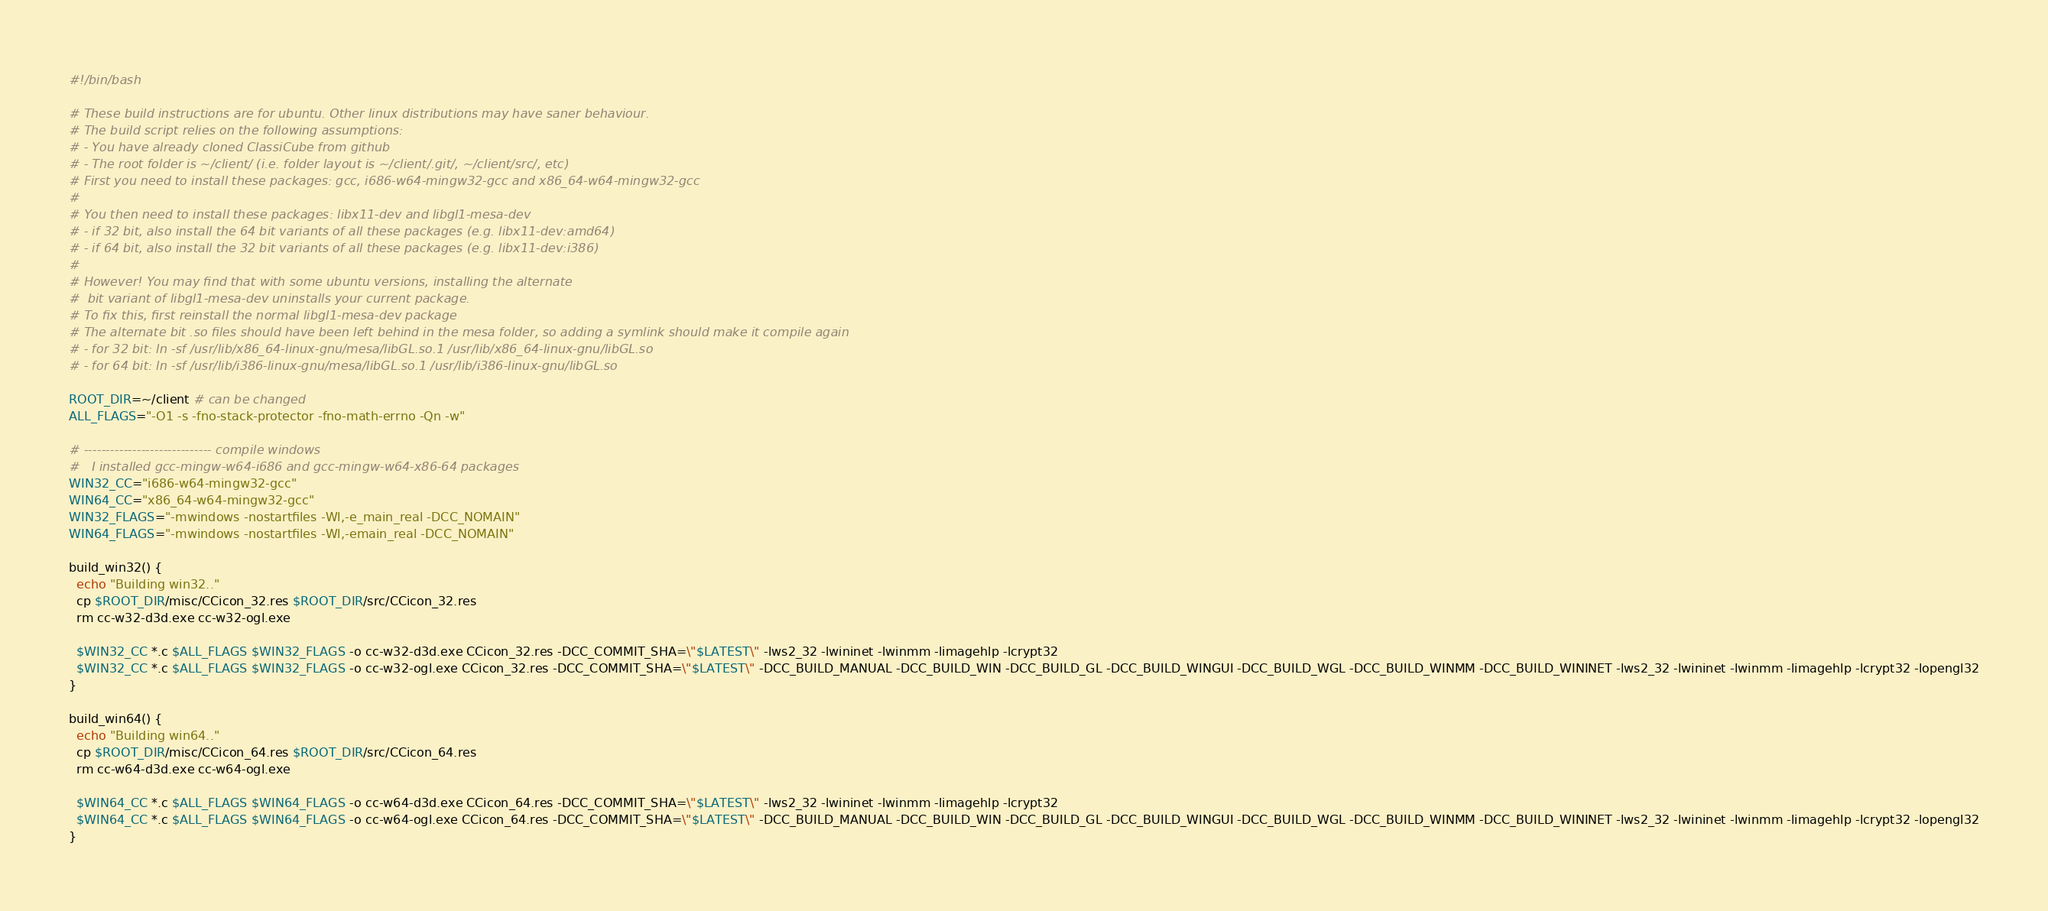<code> <loc_0><loc_0><loc_500><loc_500><_Bash_>#!/bin/bash

# These build instructions are for ubuntu. Other linux distributions may have saner behaviour.
# The build script relies on the following assumptions:
# - You have already cloned ClassiCube from github
# - The root folder is ~/client/ (i.e. folder layout is ~/client/.git/, ~/client/src/, etc)
# First you need to install these packages: gcc, i686-w64-mingw32-gcc and x86_64-w64-mingw32-gcc
# 
# You then need to install these packages: libx11-dev and libgl1-mesa-dev
# - if 32 bit, also install the 64 bit variants of all these packages (e.g. libx11-dev:amd64)
# - if 64 bit, also install the 32 bit variants of all these packages (e.g. libx11-dev:i386)
#
# However! You may find that with some ubuntu versions, installing the alternate
#  bit variant of libgl1-mesa-dev uninstalls your current package. 
# To fix this, first reinstall the normal libgl1-mesa-dev package
# The alternate bit .so files should have been left behind in the mesa folder, so adding a symlink should make it compile again
# - for 32 bit: ln -sf /usr/lib/x86_64-linux-gnu/mesa/libGL.so.1 /usr/lib/x86_64-linux-gnu/libGL.so
# - for 64 bit: ln -sf /usr/lib/i386-linux-gnu/mesa/libGL.so.1 /usr/lib/i386-linux-gnu/libGL.so

ROOT_DIR=~/client # can be changed
ALL_FLAGS="-O1 -s -fno-stack-protector -fno-math-errno -Qn -w"

# ----------------------------- compile windows
#   I installed gcc-mingw-w64-i686 and gcc-mingw-w64-x86-64 packages
WIN32_CC="i686-w64-mingw32-gcc"
WIN64_CC="x86_64-w64-mingw32-gcc"
WIN32_FLAGS="-mwindows -nostartfiles -Wl,-e_main_real -DCC_NOMAIN"
WIN64_FLAGS="-mwindows -nostartfiles -Wl,-emain_real -DCC_NOMAIN"

build_win32() {
  echo "Building win32.."
  cp $ROOT_DIR/misc/CCicon_32.res $ROOT_DIR/src/CCicon_32.res
  rm cc-w32-d3d.exe cc-w32-ogl.exe

  $WIN32_CC *.c $ALL_FLAGS $WIN32_FLAGS -o cc-w32-d3d.exe CCicon_32.res -DCC_COMMIT_SHA=\"$LATEST\" -lws2_32 -lwininet -lwinmm -limagehlp -lcrypt32
  $WIN32_CC *.c $ALL_FLAGS $WIN32_FLAGS -o cc-w32-ogl.exe CCicon_32.res -DCC_COMMIT_SHA=\"$LATEST\" -DCC_BUILD_MANUAL -DCC_BUILD_WIN -DCC_BUILD_GL -DCC_BUILD_WINGUI -DCC_BUILD_WGL -DCC_BUILD_WINMM -DCC_BUILD_WININET -lws2_32 -lwininet -lwinmm -limagehlp -lcrypt32 -lopengl32
}

build_win64() {
  echo "Building win64.."
  cp $ROOT_DIR/misc/CCicon_64.res $ROOT_DIR/src/CCicon_64.res
  rm cc-w64-d3d.exe cc-w64-ogl.exe
  
  $WIN64_CC *.c $ALL_FLAGS $WIN64_FLAGS -o cc-w64-d3d.exe CCicon_64.res -DCC_COMMIT_SHA=\"$LATEST\" -lws2_32 -lwininet -lwinmm -limagehlp -lcrypt32
  $WIN64_CC *.c $ALL_FLAGS $WIN64_FLAGS -o cc-w64-ogl.exe CCicon_64.res -DCC_COMMIT_SHA=\"$LATEST\" -DCC_BUILD_MANUAL -DCC_BUILD_WIN -DCC_BUILD_GL -DCC_BUILD_WINGUI -DCC_BUILD_WGL -DCC_BUILD_WINMM -DCC_BUILD_WININET -lws2_32 -lwininet -lwinmm -limagehlp -lcrypt32 -lopengl32
}
</code> 